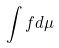<formula> <loc_0><loc_0><loc_500><loc_500>\int f d \mu</formula> 